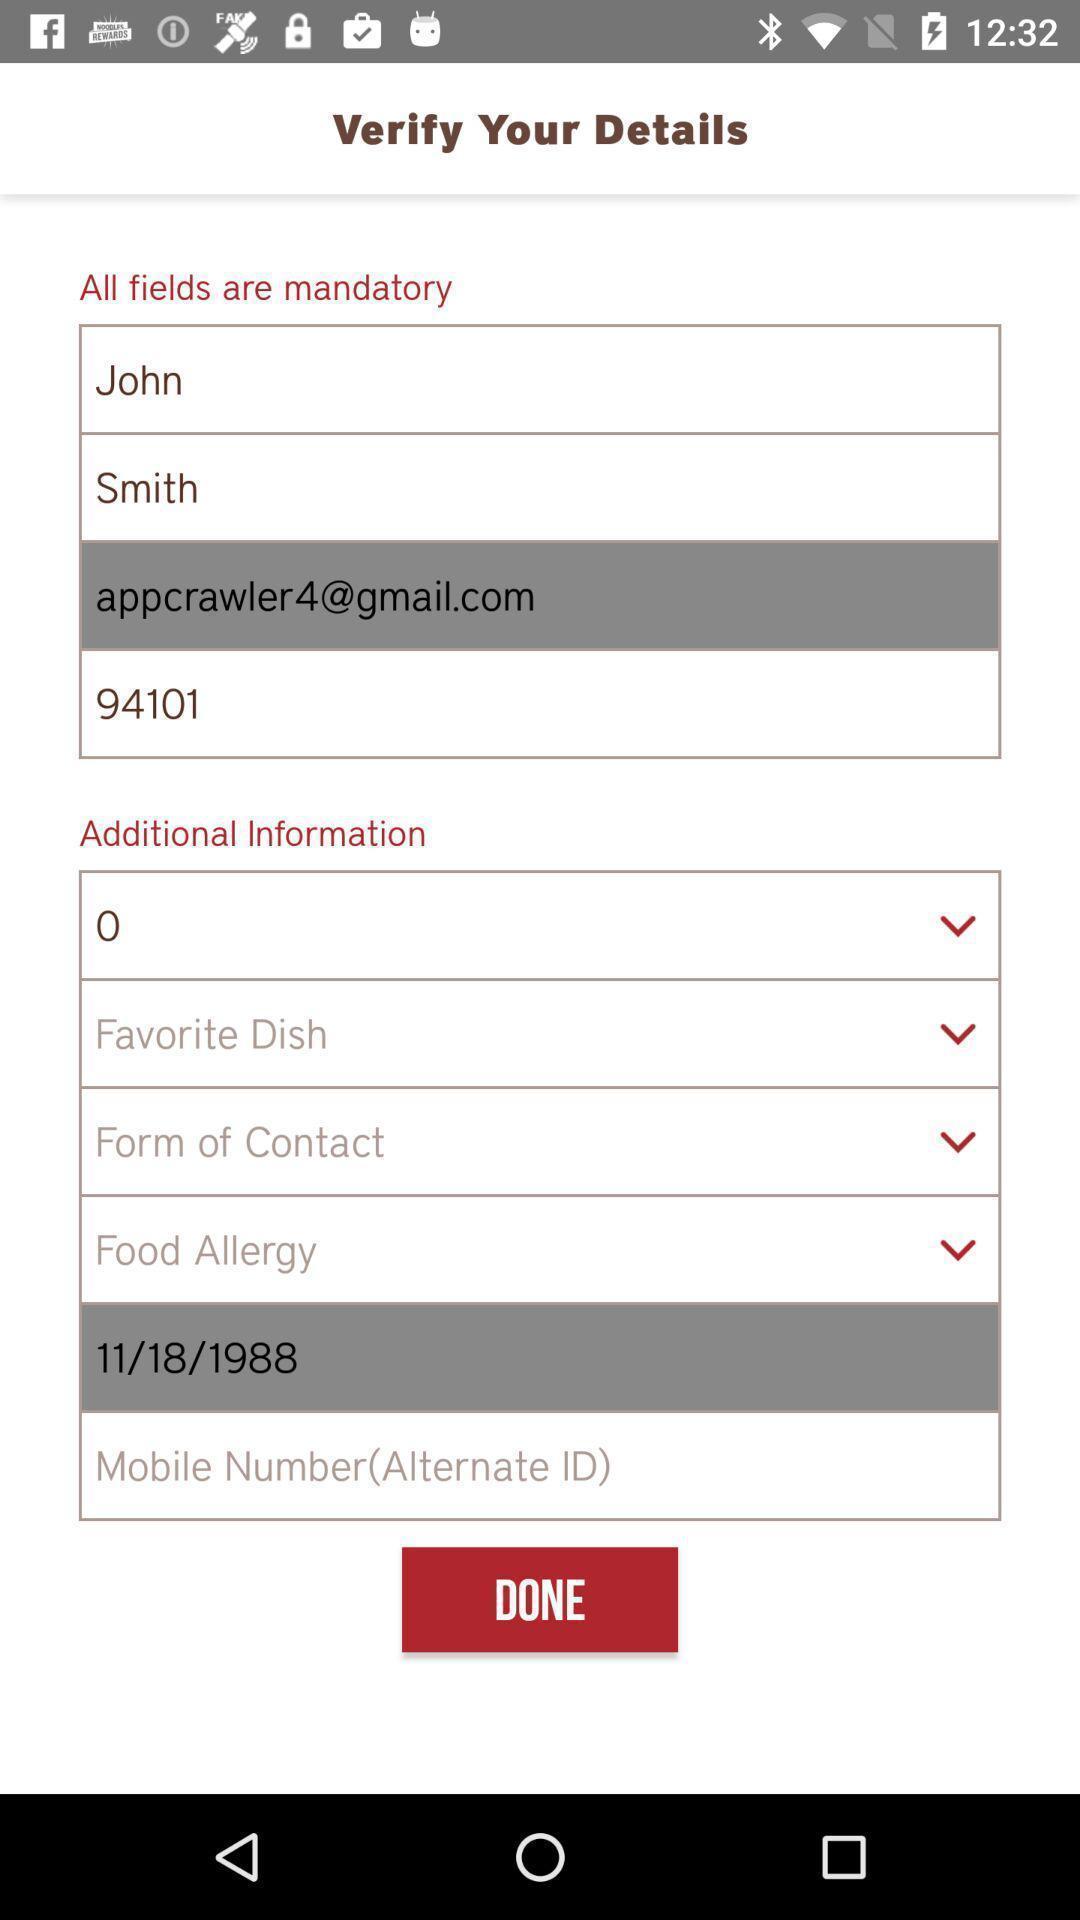Provide a textual representation of this image. Verification of details of the user of food app. 